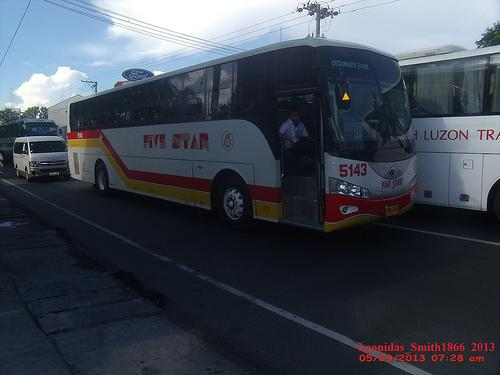What type of power lines are present in the image? Overhead power lines connecting at a tall pole. Describe the appearance of the bus. The bus has various numbers and letters, a red name and number, an open door, a front windshield, a rear wheel, a front tire, a headlight, and a blue ford sign on its body. Determine the sentiment of the image based on its content. The image has a neutral sentiment with regular city life activity. Count the total number of vehicles present in the image. Three vehicles: a white van, a bus, and a white bus behind the travel bus. List the main objects in the image. White van, bus, wheel, headlight, open door, young man, blue ford sign, power lines, windshield, rear wheel, numbers, letters, red name, red number, stripe, road, white line, clouds, tire, tree, license plate. Explain what is happening on the road in the picture. There is a white van following a bus and a white bus behind the travel bus on a dark grey road with a white line. Identify the colors and type of stripe on the bus. Red and orange stripe on the side of the bus. Assess the overall image quality based on the visibility of the objects. The image quality is good, as most objects are clearly visible and well-defined. What is the weather like in the image? The sky is blue and white with puffy clouds, suggesting a pleasant day. Describe the interaction between the vehicles in the image. The white van is following the bus, and behind the travel bus, there is a white bus. 